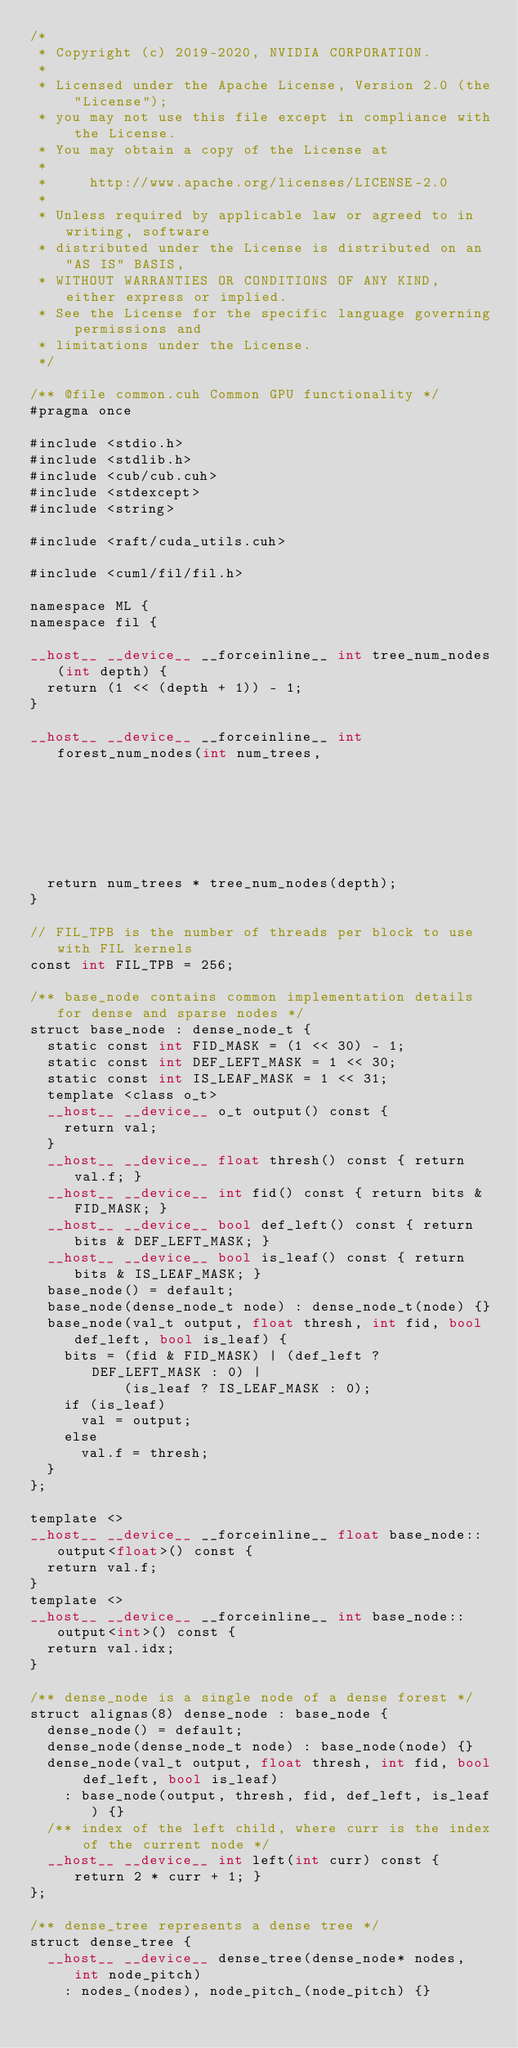Convert code to text. <code><loc_0><loc_0><loc_500><loc_500><_Cuda_>/*
 * Copyright (c) 2019-2020, NVIDIA CORPORATION.
 *
 * Licensed under the Apache License, Version 2.0 (the "License");
 * you may not use this file except in compliance with the License.
 * You may obtain a copy of the License at
 *
 *     http://www.apache.org/licenses/LICENSE-2.0
 *
 * Unless required by applicable law or agreed to in writing, software
 * distributed under the License is distributed on an "AS IS" BASIS,
 * WITHOUT WARRANTIES OR CONDITIONS OF ANY KIND, either express or implied.
 * See the License for the specific language governing permissions and
 * limitations under the License.
 */

/** @file common.cuh Common GPU functionality */
#pragma once

#include <stdio.h>
#include <stdlib.h>
#include <cub/cub.cuh>
#include <stdexcept>
#include <string>

#include <raft/cuda_utils.cuh>

#include <cuml/fil/fil.h>

namespace ML {
namespace fil {

__host__ __device__ __forceinline__ int tree_num_nodes(int depth) {
  return (1 << (depth + 1)) - 1;
}

__host__ __device__ __forceinline__ int forest_num_nodes(int num_trees,
                                                         int depth) {
  return num_trees * tree_num_nodes(depth);
}

// FIL_TPB is the number of threads per block to use with FIL kernels
const int FIL_TPB = 256;

/** base_node contains common implementation details for dense and sparse nodes */
struct base_node : dense_node_t {
  static const int FID_MASK = (1 << 30) - 1;
  static const int DEF_LEFT_MASK = 1 << 30;
  static const int IS_LEAF_MASK = 1 << 31;
  template <class o_t>
  __host__ __device__ o_t output() const {
    return val;
  }
  __host__ __device__ float thresh() const { return val.f; }
  __host__ __device__ int fid() const { return bits & FID_MASK; }
  __host__ __device__ bool def_left() const { return bits & DEF_LEFT_MASK; }
  __host__ __device__ bool is_leaf() const { return bits & IS_LEAF_MASK; }
  base_node() = default;
  base_node(dense_node_t node) : dense_node_t(node) {}
  base_node(val_t output, float thresh, int fid, bool def_left, bool is_leaf) {
    bits = (fid & FID_MASK) | (def_left ? DEF_LEFT_MASK : 0) |
           (is_leaf ? IS_LEAF_MASK : 0);
    if (is_leaf)
      val = output;
    else
      val.f = thresh;
  }
};

template <>
__host__ __device__ __forceinline__ float base_node::output<float>() const {
  return val.f;
}
template <>
__host__ __device__ __forceinline__ int base_node::output<int>() const {
  return val.idx;
}

/** dense_node is a single node of a dense forest */
struct alignas(8) dense_node : base_node {
  dense_node() = default;
  dense_node(dense_node_t node) : base_node(node) {}
  dense_node(val_t output, float thresh, int fid, bool def_left, bool is_leaf)
    : base_node(output, thresh, fid, def_left, is_leaf) {}
  /** index of the left child, where curr is the index of the current node */
  __host__ __device__ int left(int curr) const { return 2 * curr + 1; }
};

/** dense_tree represents a dense tree */
struct dense_tree {
  __host__ __device__ dense_tree(dense_node* nodes, int node_pitch)
    : nodes_(nodes), node_pitch_(node_pitch) {}</code> 